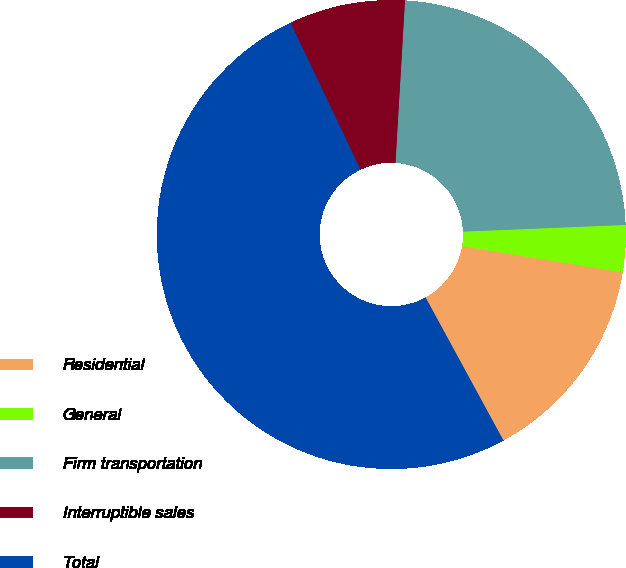Convert chart. <chart><loc_0><loc_0><loc_500><loc_500><pie_chart><fcel>Residential<fcel>General<fcel>Firm transportation<fcel>Interruptible sales<fcel>Total<nl><fcel>14.48%<fcel>3.24%<fcel>23.42%<fcel>8.0%<fcel>50.86%<nl></chart> 